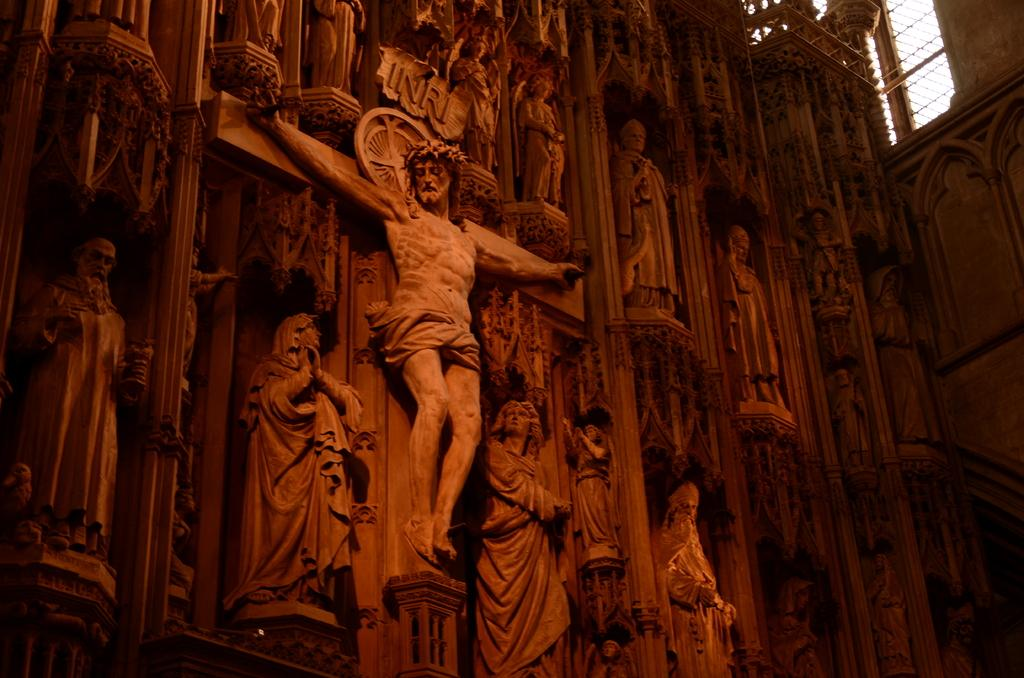What can be seen on the wall in the image? There are statues on the wall in the image. What type of material is the fang made of in the image? There is no fang present in the image; it only features statues on the wall. 